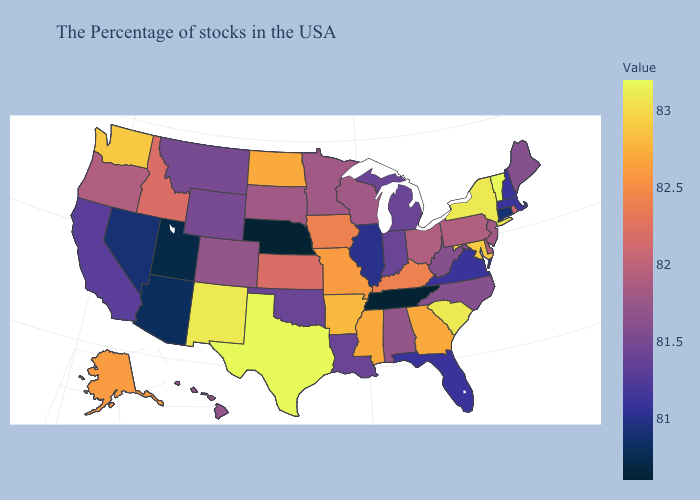Is the legend a continuous bar?
Answer briefly. Yes. Does New Jersey have a higher value than Iowa?
Answer briefly. No. Among the states that border Nebraska , does Colorado have the lowest value?
Answer briefly. No. Which states hav the highest value in the West?
Give a very brief answer. New Mexico. Does Texas have the highest value in the USA?
Short answer required. Yes. 